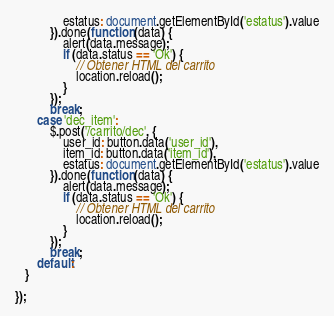Convert code to text. <code><loc_0><loc_0><loc_500><loc_500><_JavaScript_>               estatus: document.getElementById('estatus').value
           }).done(function (data) {
               alert(data.message);
               if (data.status == 'Ok') {
                   // Obtener HTML del carrito
                   location.reload();
               }
           });
           break;
       case 'dec_item':
           $.post('/carrito/dec', {
               user_id: button.data('user_id'),
               item_id: button.data('item_id'),
               estatus: document.getElementById('estatus').value
           }).done(function (data) {
               alert(data.message);
               if (data.status == 'Ok') {
                   // Obtener HTML del carrito
                   location.reload();
               }
           });
           break;
       default:
   }

});
</code> 